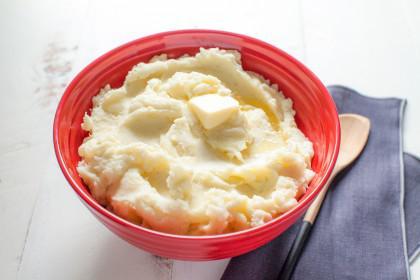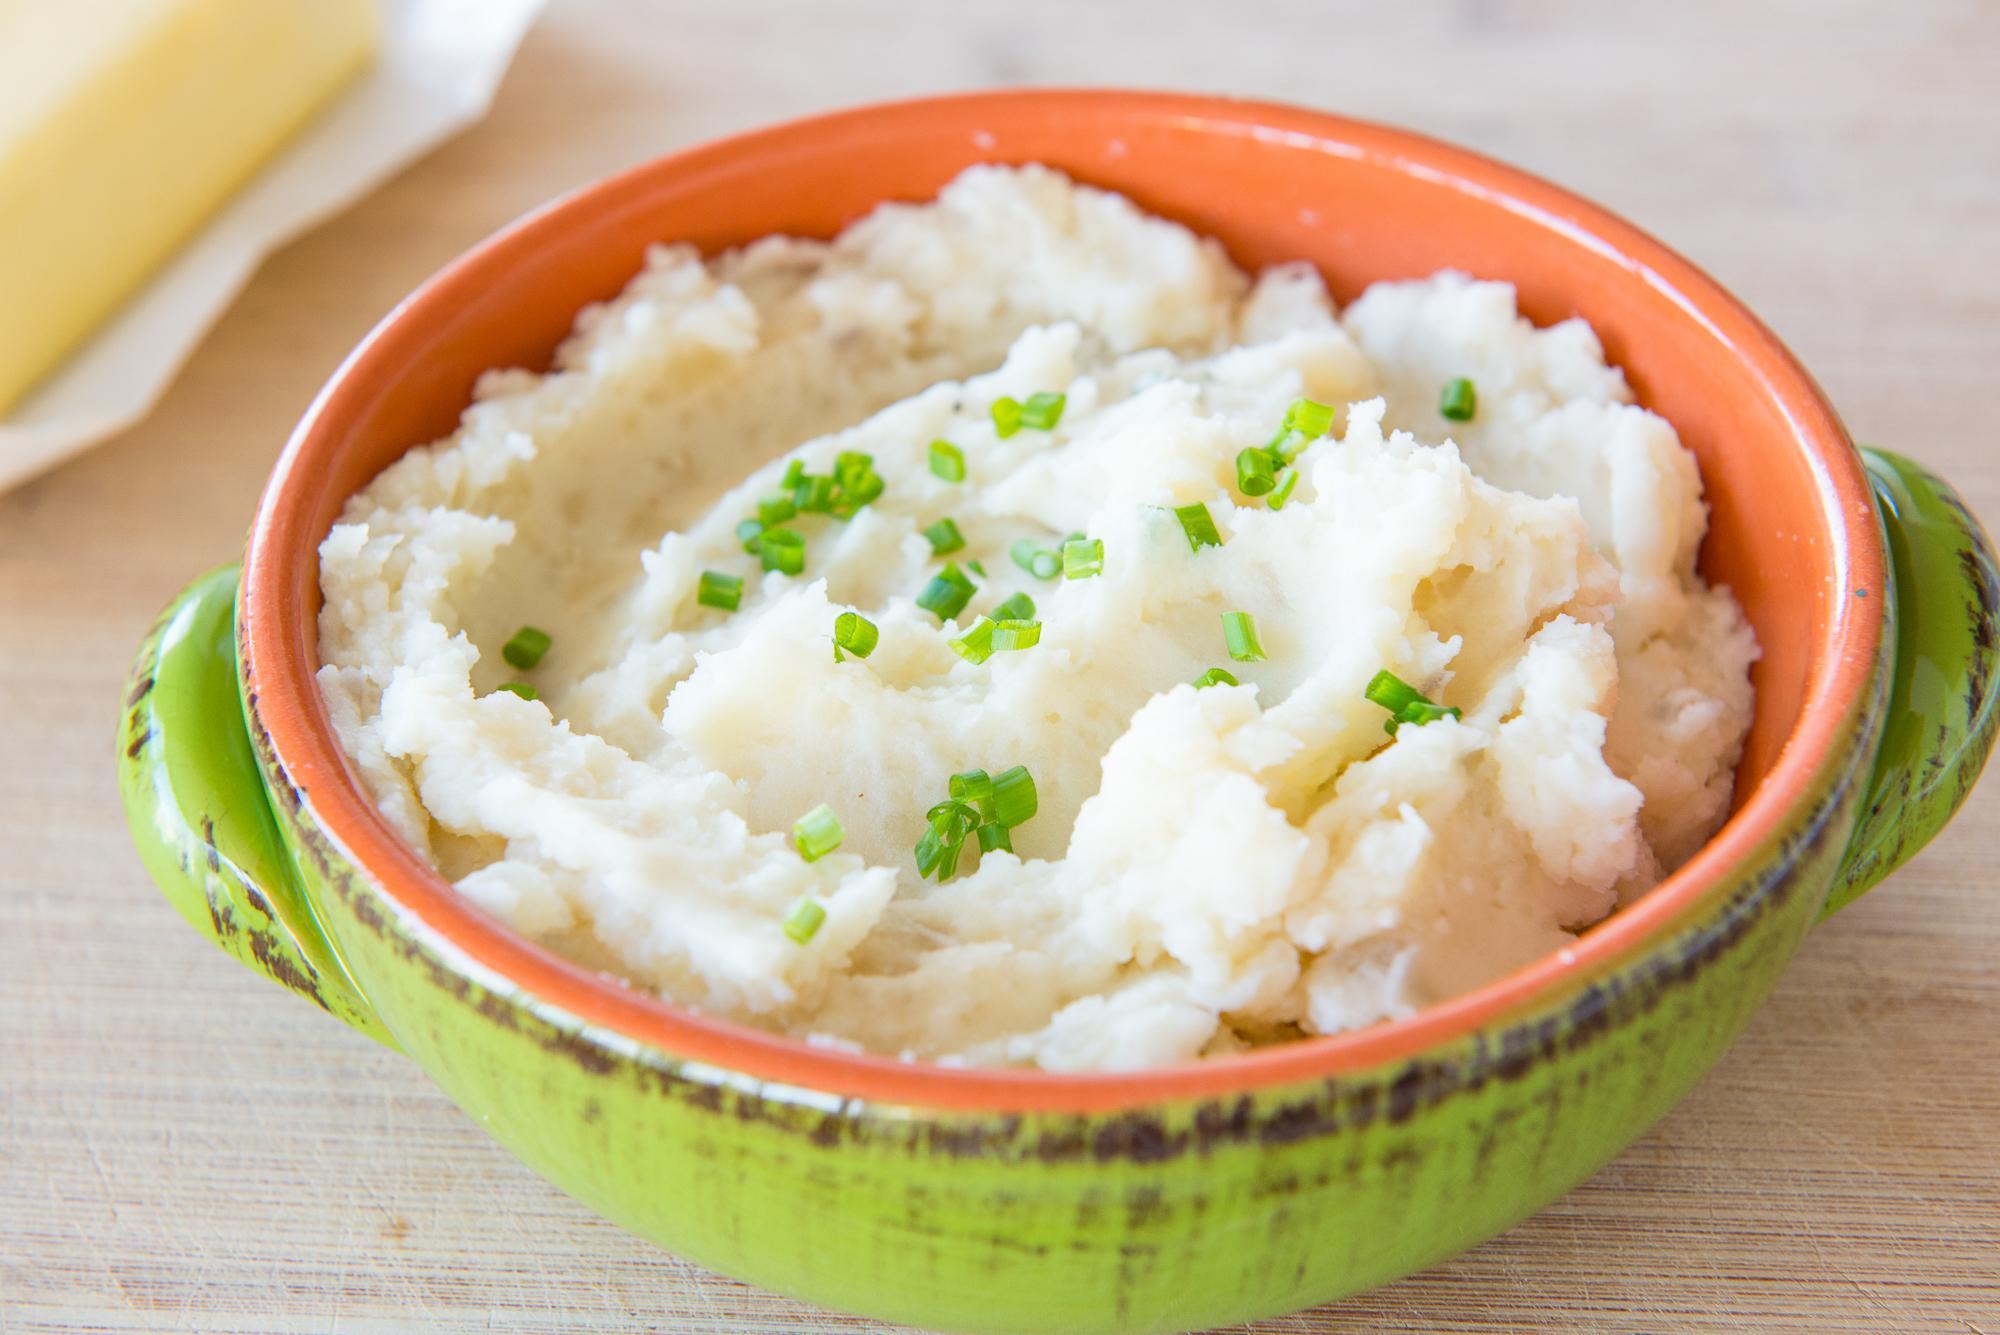The first image is the image on the left, the second image is the image on the right. Assess this claim about the two images: "One image shows mashed potatoes served in a lime-green bowl.". Correct or not? Answer yes or no. Yes. 